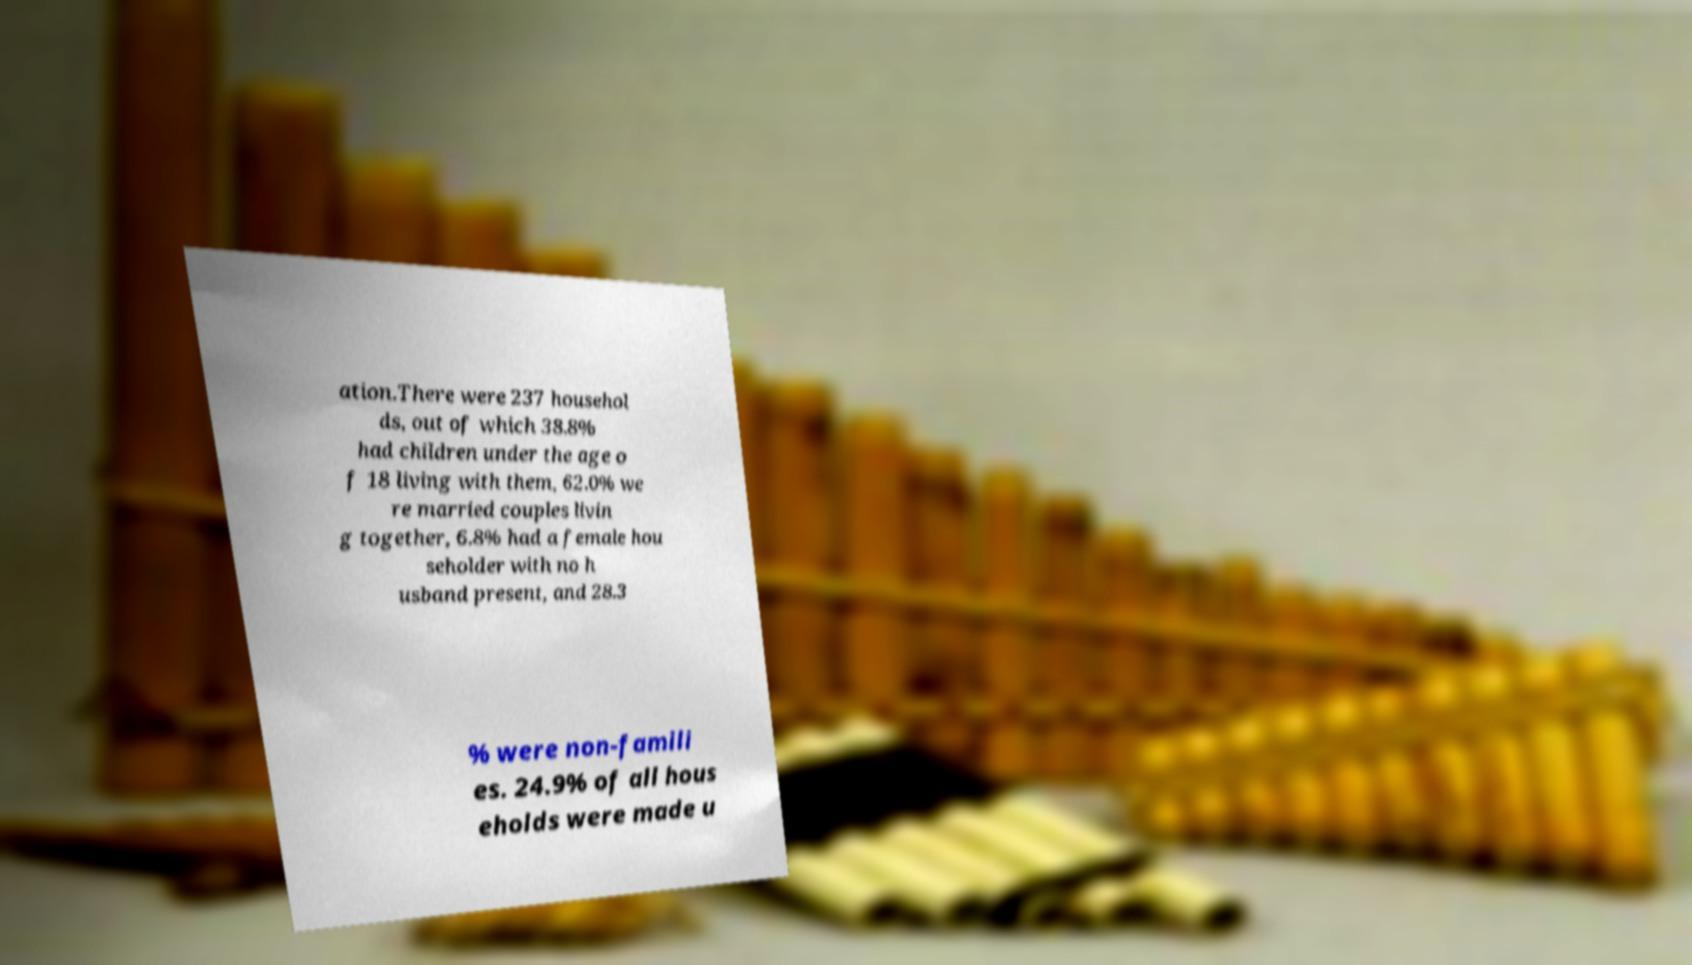There's text embedded in this image that I need extracted. Can you transcribe it verbatim? ation.There were 237 househol ds, out of which 38.8% had children under the age o f 18 living with them, 62.0% we re married couples livin g together, 6.8% had a female hou seholder with no h usband present, and 28.3 % were non-famili es. 24.9% of all hous eholds were made u 